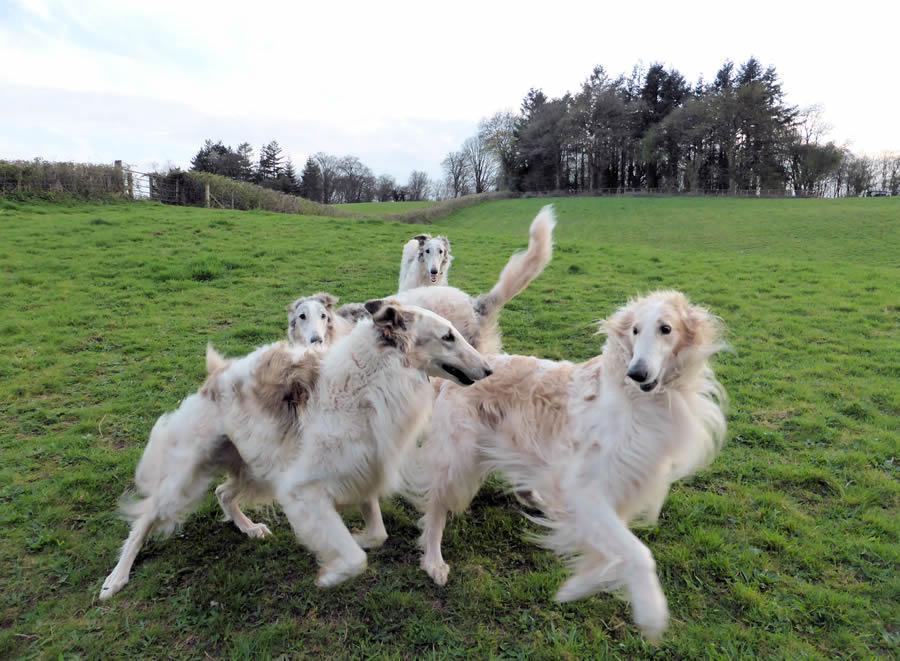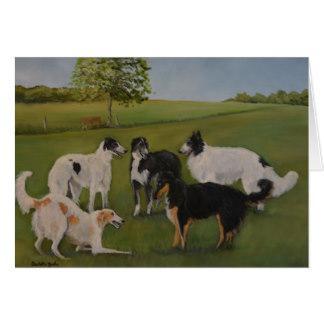The first image is the image on the left, the second image is the image on the right. For the images shown, is this caption "At least one person is outside with the dogs in the image on the right." true? Answer yes or no. No. 